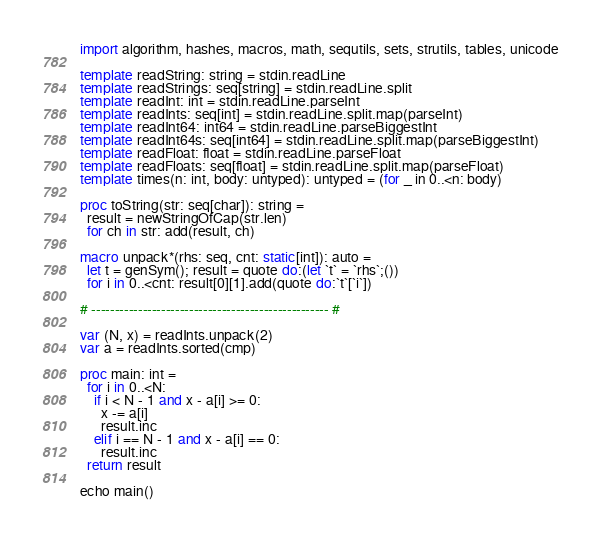Convert code to text. <code><loc_0><loc_0><loc_500><loc_500><_Nim_>import algorithm, hashes, macros, math, sequtils, sets, strutils, tables, unicode

template readString: string = stdin.readLine
template readStrings: seq[string] = stdin.readLine.split
template readInt: int = stdin.readLine.parseInt
template readInts: seq[int] = stdin.readLine.split.map(parseInt)
template readInt64: int64 = stdin.readLine.parseBiggestInt
template readInt64s: seq[int64] = stdin.readLine.split.map(parseBiggestInt)
template readFloat: float = stdin.readLine.parseFloat
template readFloats: seq[float] = stdin.readLine.split.map(parseFloat)
template times(n: int, body: untyped): untyped = (for _ in 0..<n: body)

proc toString(str: seq[char]): string =
  result = newStringOfCap(str.len)
  for ch in str: add(result, ch)

macro unpack*(rhs: seq, cnt: static[int]): auto =
  let t = genSym(); result = quote do:(let `t` = `rhs`;())
  for i in 0..<cnt: result[0][1].add(quote do:`t`[`i`])

# --------------------------------------------------- #

var (N, x) = readInts.unpack(2)
var a = readInts.sorted(cmp)

proc main: int =
  for i in 0..<N:
    if i < N - 1 and x - a[i] >= 0:
      x -= a[i]
      result.inc
    elif i == N - 1 and x - a[i] == 0:
      result.inc
  return result

echo main()</code> 